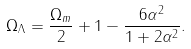Convert formula to latex. <formula><loc_0><loc_0><loc_500><loc_500>\Omega _ { \Lambda } = \frac { \Omega _ { m } } { 2 } + 1 - \frac { 6 \alpha ^ { 2 } } { 1 + 2 \alpha ^ { 2 } } .</formula> 